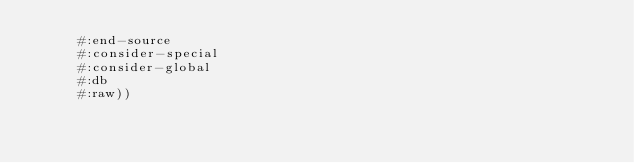<code> <loc_0><loc_0><loc_500><loc_500><_Lisp_>	   #:end-source
	   #:consider-special
	   #:consider-global
	   #:db
	   #:raw))
</code> 